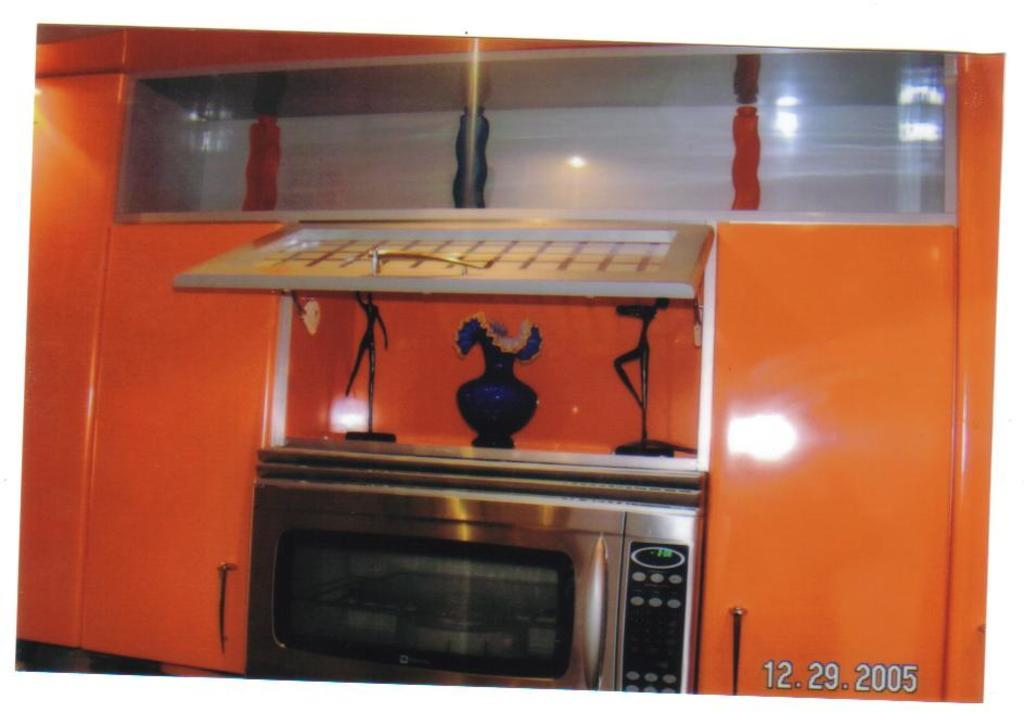What type of appliance is located at the bottom side of the image? There is an oven at the bottom side of the image. What type of furniture is present in the image? There are cupboards in the image. What can be seen in the center of the image? There is a flower vase in the center of the image. Can you tell me how many self-suggestions are made by the flower vase in the image? There are no self-suggestions made by the flower vase in the image, as it is an inanimate object and cannot make suggestions. 